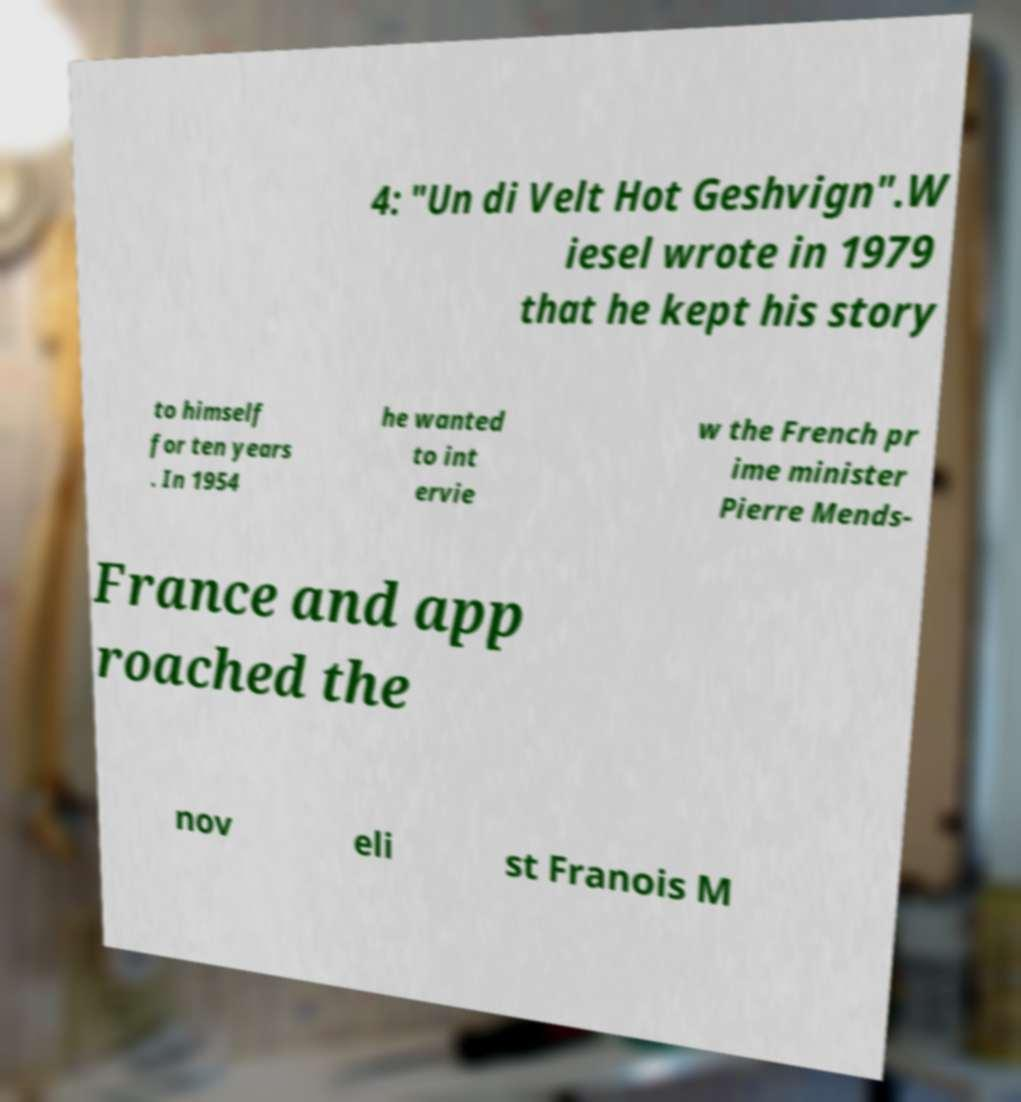I need the written content from this picture converted into text. Can you do that? 4: "Un di Velt Hot Geshvign".W iesel wrote in 1979 that he kept his story to himself for ten years . In 1954 he wanted to int ervie w the French pr ime minister Pierre Mends- France and app roached the nov eli st Franois M 